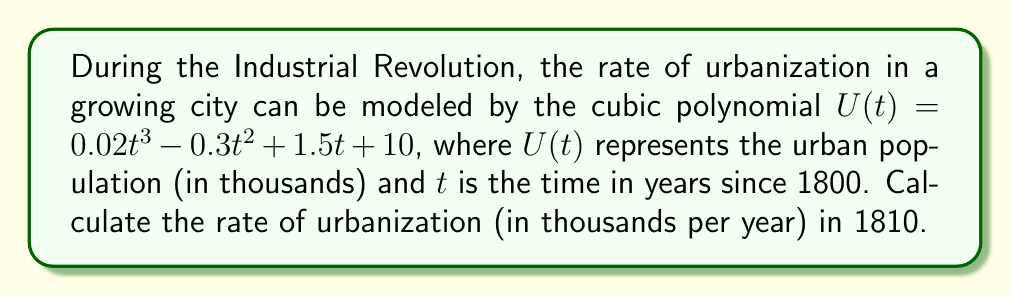What is the answer to this math problem? To find the rate of urbanization, we need to calculate the derivative of the given function $U(t)$ and evaluate it at $t = 10$ (since 1810 is 10 years after 1800).

Step 1: Find the derivative of $U(t)$.
$$\frac{d}{dt}U(t) = \frac{d}{dt}(0.02t^3 - 0.3t^2 + 1.5t + 10)$$
$$U'(t) = 0.06t^2 - 0.6t + 1.5$$

Step 2: Evaluate $U'(t)$ at $t = 10$.
$$U'(10) = 0.06(10)^2 - 0.6(10) + 1.5$$
$$U'(10) = 0.06(100) - 6 + 1.5$$
$$U'(10) = 6 - 6 + 1.5$$
$$U'(10) = 1.5$$

The rate of urbanization in 1810 is 1.5 thousand people per year.
Answer: 1.5 thousand people/year 